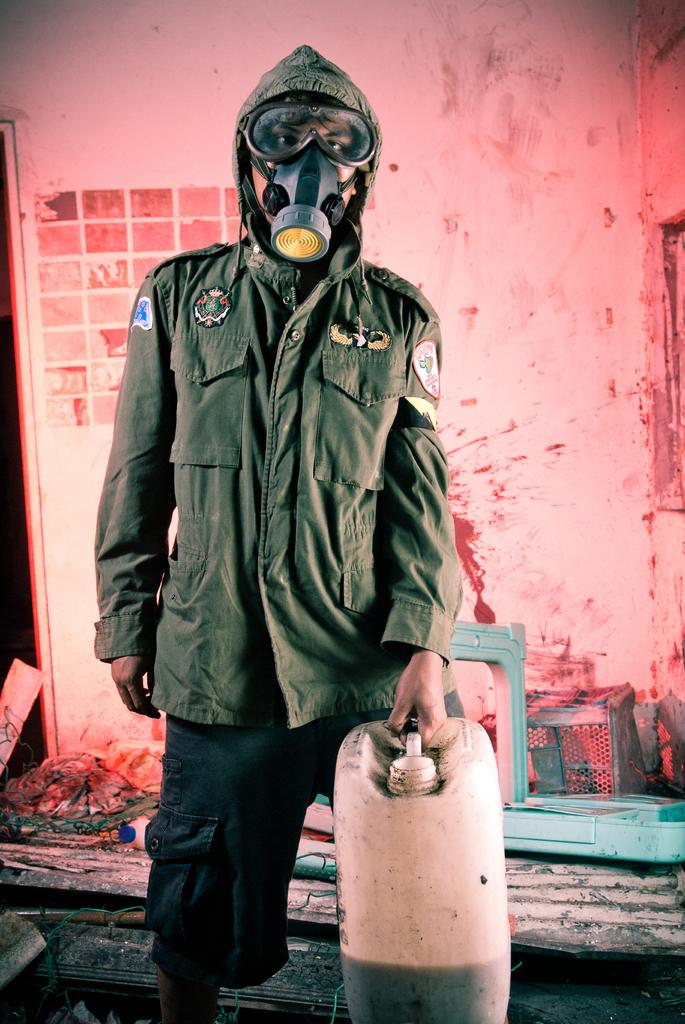What is the person in the image doing? The person is standing in the image and holding a can. What is the person wearing in the image? The person is wearing an oxygen mask in the image. What can be seen on the floor in the background of the image? There are objects lying on the floor in the background of the image. What is visible behind the person in the image? There is a wall visible in the background. How does the wren contribute to the quiet atmosphere in the image? There is no wren present in the image, so it cannot contribute to the atmosphere. 